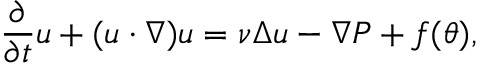<formula> <loc_0><loc_0><loc_500><loc_500>\frac { \partial } { \partial t } u + ( u \cdot \nabla ) u = \nu \Delta u - \nabla P + f ( \theta ) ,</formula> 